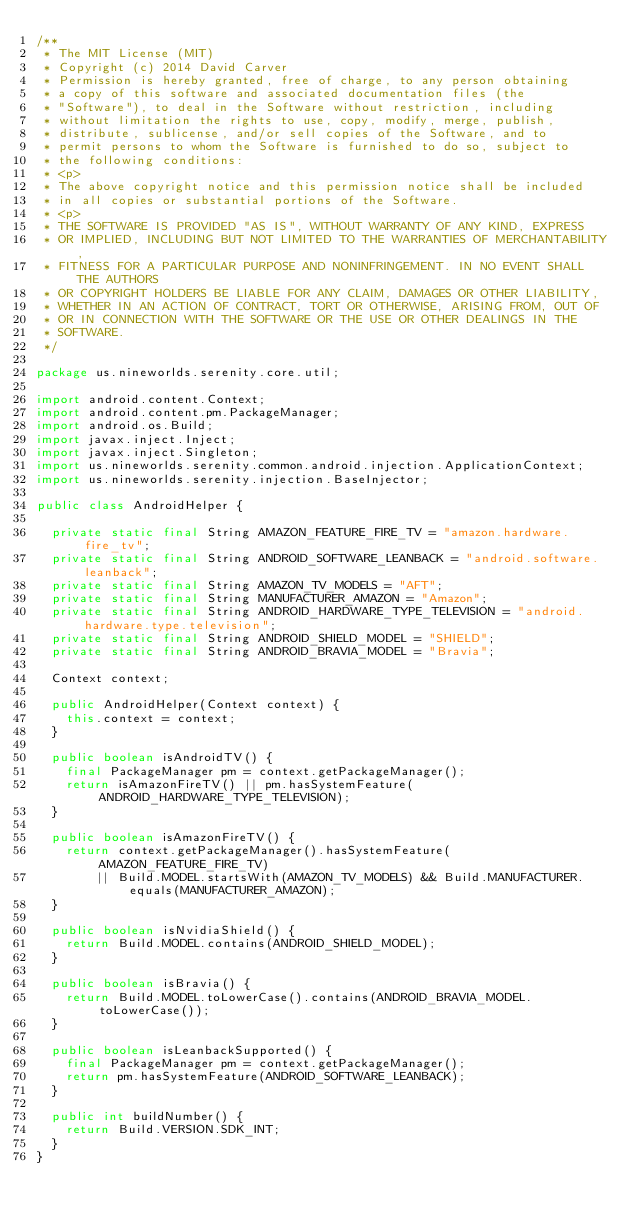Convert code to text. <code><loc_0><loc_0><loc_500><loc_500><_Java_>/**
 * The MIT License (MIT)
 * Copyright (c) 2014 David Carver
 * Permission is hereby granted, free of charge, to any person obtaining
 * a copy of this software and associated documentation files (the
 * "Software"), to deal in the Software without restriction, including
 * without limitation the rights to use, copy, modify, merge, publish,
 * distribute, sublicense, and/or sell copies of the Software, and to
 * permit persons to whom the Software is furnished to do so, subject to
 * the following conditions:
 * <p>
 * The above copyright notice and this permission notice shall be included
 * in all copies or substantial portions of the Software.
 * <p>
 * THE SOFTWARE IS PROVIDED "AS IS", WITHOUT WARRANTY OF ANY KIND, EXPRESS
 * OR IMPLIED, INCLUDING BUT NOT LIMITED TO THE WARRANTIES OF MERCHANTABILITY,
 * FITNESS FOR A PARTICULAR PURPOSE AND NONINFRINGEMENT. IN NO EVENT SHALL THE AUTHORS
 * OR COPYRIGHT HOLDERS BE LIABLE FOR ANY CLAIM, DAMAGES OR OTHER LIABILITY,
 * WHETHER IN AN ACTION OF CONTRACT, TORT OR OTHERWISE, ARISING FROM, OUT OF
 * OR IN CONNECTION WITH THE SOFTWARE OR THE USE OR OTHER DEALINGS IN THE
 * SOFTWARE.
 */

package us.nineworlds.serenity.core.util;

import android.content.Context;
import android.content.pm.PackageManager;
import android.os.Build;
import javax.inject.Inject;
import javax.inject.Singleton;
import us.nineworlds.serenity.common.android.injection.ApplicationContext;
import us.nineworlds.serenity.injection.BaseInjector;

public class AndroidHelper {

  private static final String AMAZON_FEATURE_FIRE_TV = "amazon.hardware.fire_tv";
  private static final String ANDROID_SOFTWARE_LEANBACK = "android.software.leanback";
  private static final String AMAZON_TV_MODELS = "AFT";
  private static final String MANUFACTURER_AMAZON = "Amazon";
  private static final String ANDROID_HARDWARE_TYPE_TELEVISION = "android.hardware.type.television";
  private static final String ANDROID_SHIELD_MODEL = "SHIELD";
  private static final String ANDROID_BRAVIA_MODEL = "Bravia";

  Context context;

  public AndroidHelper(Context context) {
    this.context = context;
  }

  public boolean isAndroidTV() {
    final PackageManager pm = context.getPackageManager();
    return isAmazonFireTV() || pm.hasSystemFeature(ANDROID_HARDWARE_TYPE_TELEVISION);
  }

  public boolean isAmazonFireTV() {
    return context.getPackageManager().hasSystemFeature(AMAZON_FEATURE_FIRE_TV)
        || Build.MODEL.startsWith(AMAZON_TV_MODELS) && Build.MANUFACTURER.equals(MANUFACTURER_AMAZON);
  }

  public boolean isNvidiaShield() {
    return Build.MODEL.contains(ANDROID_SHIELD_MODEL);
  }

  public boolean isBravia() {
    return Build.MODEL.toLowerCase().contains(ANDROID_BRAVIA_MODEL.toLowerCase());
  }

  public boolean isLeanbackSupported() {
    final PackageManager pm = context.getPackageManager();
    return pm.hasSystemFeature(ANDROID_SOFTWARE_LEANBACK);
  }

  public int buildNumber() {
    return Build.VERSION.SDK_INT;
  }
}
</code> 